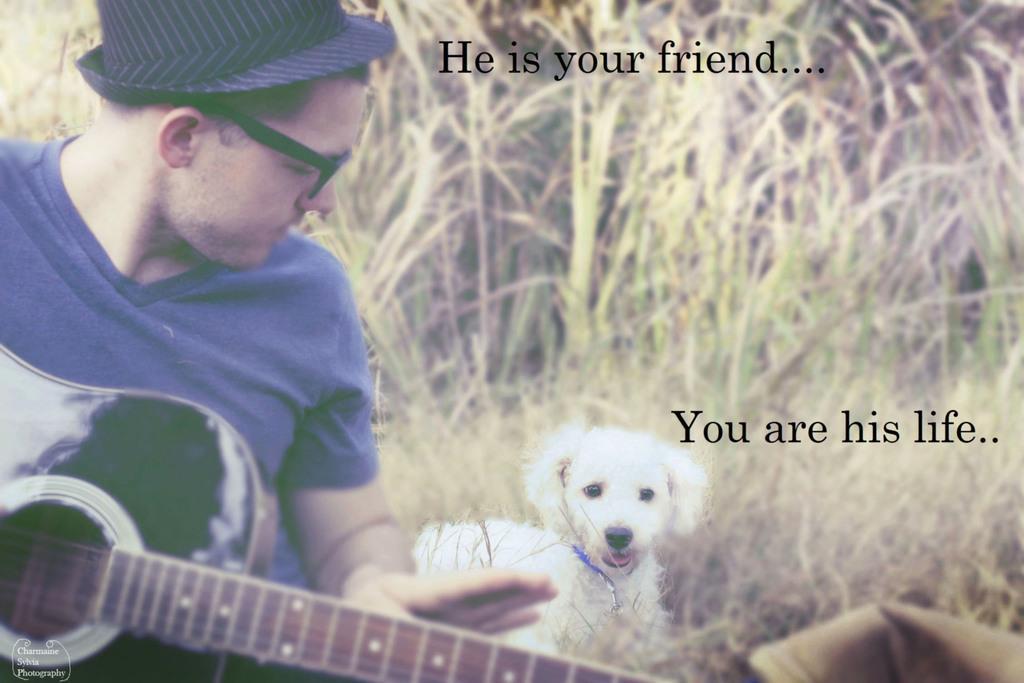How would you summarize this image in a sentence or two? In the middle there is a beautiful white dog. On the left a man is sitting and holding guitar he wear blue t shirt ,hat an shades. In the back ground there is ,a text written on image , and plants ,grass. 